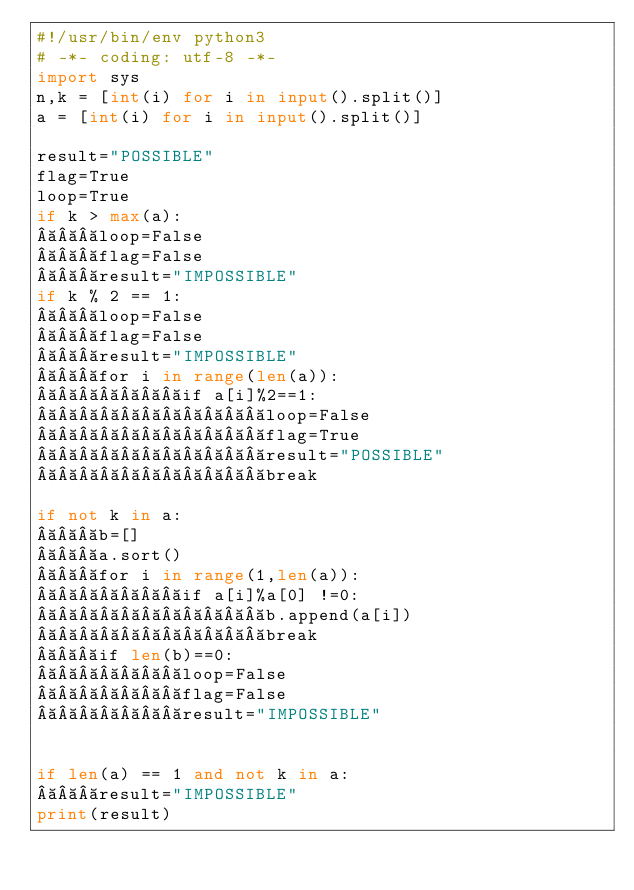<code> <loc_0><loc_0><loc_500><loc_500><_Python_>#!/usr/bin/env python3
# -*- coding: utf-8 -*-
import sys
n,k = [int(i) for i in input().split()]
a = [int(i) for i in input().split()]

result="POSSIBLE"
flag=True
loop=True
if k > max(a):
   loop=False
   flag=False
   result="IMPOSSIBLE"
if k % 2 == 1:
   loop=False
   flag=False
   result="IMPOSSIBLE"
   for i in range(len(a)):
       if a[i]%2==1:
           loop=False
           flag=True
           result="POSSIBLE"
           break

if not k in a:
   b=[]
   a.sort()
   for i in range(1,len(a)):
       if a[i]%a[0] !=0:
           b.append(a[i])
           break
   if len(b)==0:
       loop=False
       flag=False
       result="IMPOSSIBLE"


if len(a) == 1 and not k in a:
   result="IMPOSSIBLE"
print(result) </code> 